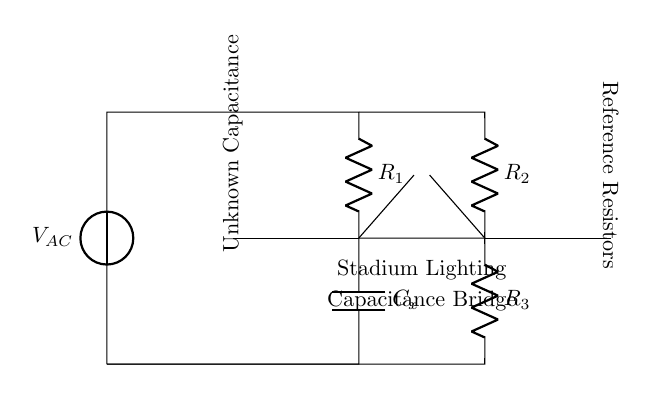What is the input voltage type for this circuit? The diagram indicates a voltage source labeled V_AC, which signifies that the input voltage type is alternating current.
Answer: alternating current What components are used in this circuit diagram? The circuit diagram includes a voltage source (V_AC), two resistors (R_1 and R_2), a capacitor (C_x), and a third resistor (R_3).
Answer: voltage source, resistors, capacitor How many resistors are present in the circuit? There are three resistors indicated in the diagram: R_1, R_2, and R_3.
Answer: three What is the role of C_x in this circuit? C_x represents an unknown capacitance that is being tested using the AC bridge configuration, aiming to determine its value based on the balance of resistances in the circuit.
Answer: unknown capacitance What is the purpose of the detector in the circuit? The detector is used to sense the balance condition in the circuit, indicating when the bridge is balanced, which is essential for accurately measuring capacitance.
Answer: sense balance condition What does the notation at the bottom (Stadium Lighting) represent? The notation indicates that the context of this circuit relates specifically to the stadium lighting systems, suggesting its application in testing capacitors related to such installations.
Answer: stadium lighting systems How can you identify the reference resistors in the circuit? The reference resistors are identified on the right side of the diagram, where it mentions "Reference Resistors," helping to distinguish them from other components in the circuit.
Answer: reference resistors 